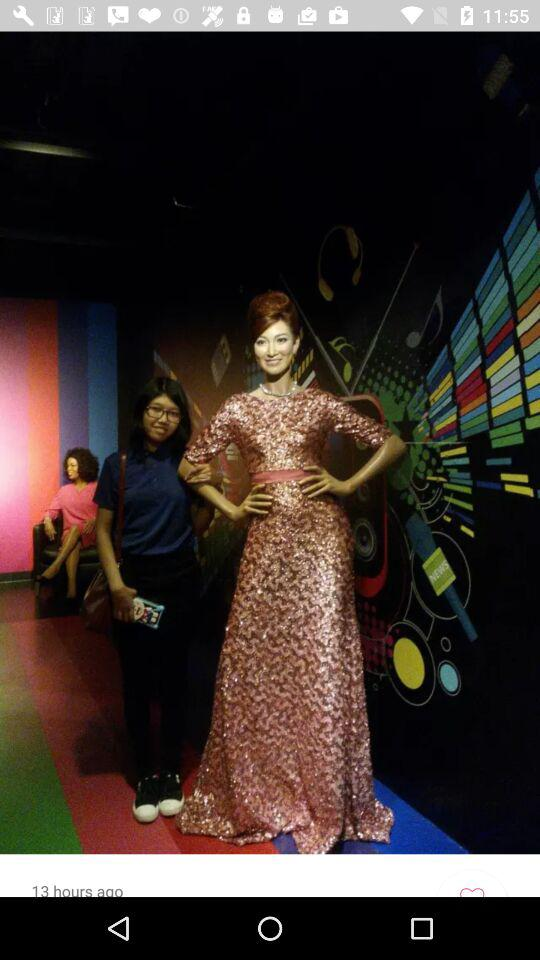How long ago was the photo uploaded? The photo was uploaded 13 hours ago. 